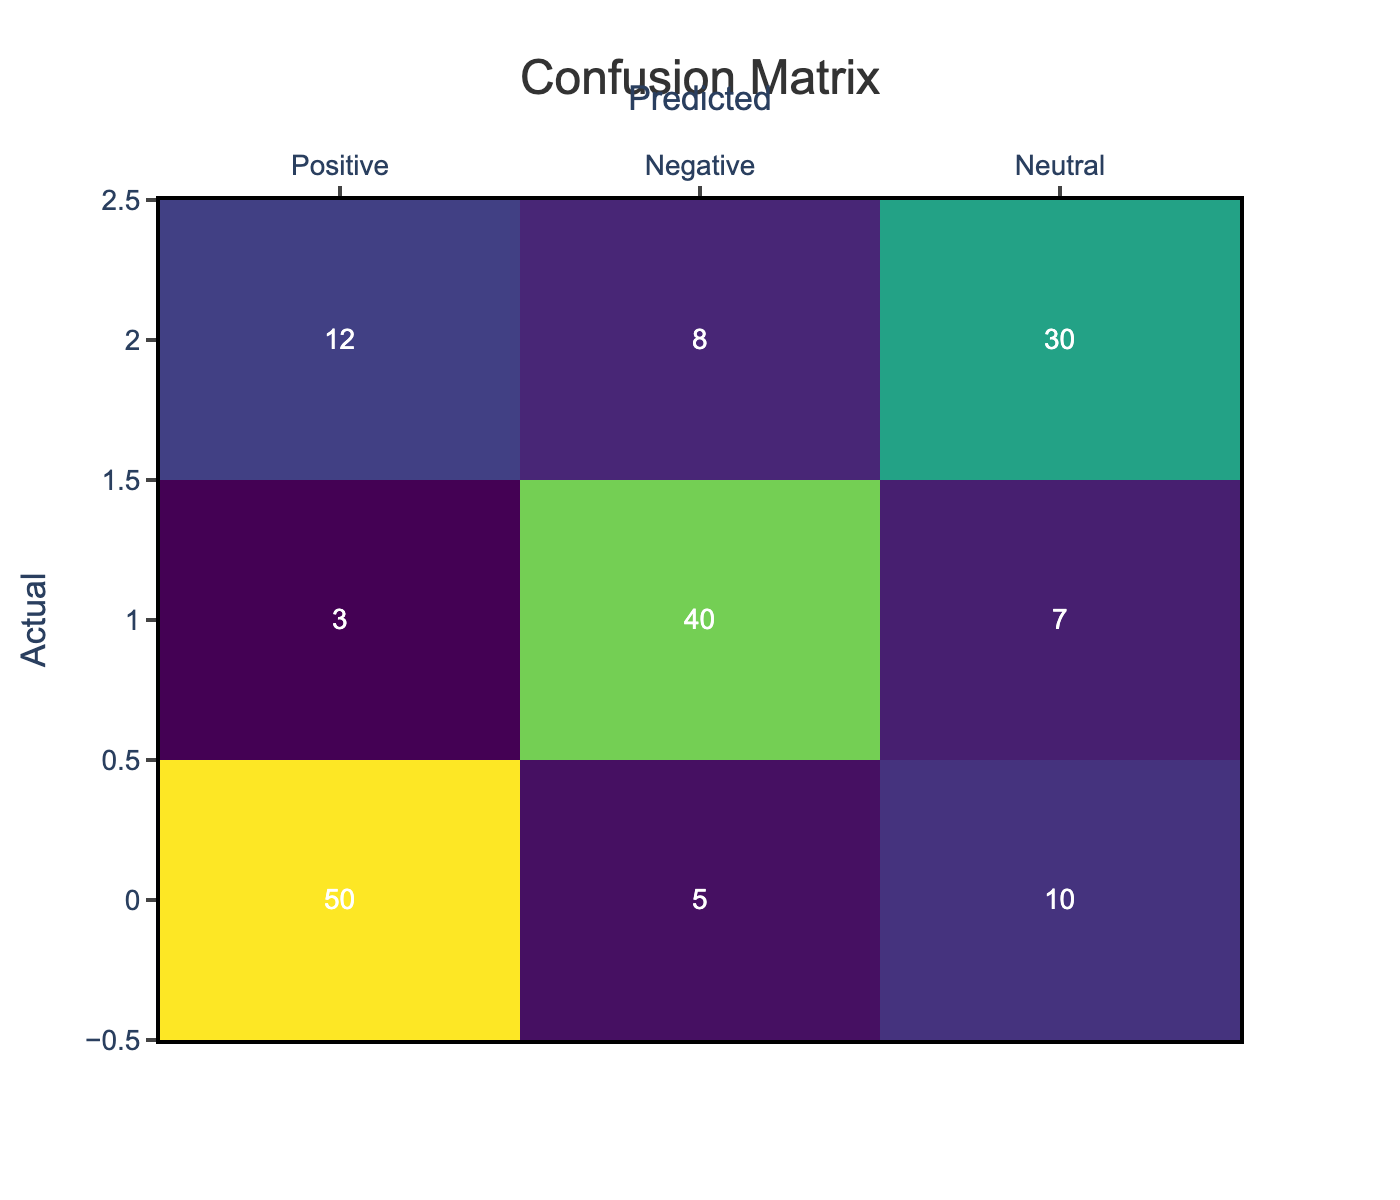What is the total number of actual positive cases? The actual positive cases are located in the first row of the table. To find the total, I add the values in the first row: 50 (True Positive) + 5 (False Negative) + 10 (Neutral) = 65.
Answer: 65 How many cases were incorrectly classified as negative? The cases incorrectly classified as negative are represented by the False Negative value within the Negative row. From the table, the False Negative cases (3) correspond to actual positives predicted as negatives, while the True Negative (40) represents the negatives correctly predicted.
Answer: 3 What is the total number of predicted neutral cases? To find the total predicted neutral cases, I need to look at the Neutral column. I will sum the values from all three rows: 10 (Positive) + 7 (Negative) + 30 (Neutral) = 47 predicted as neutral.
Answer: 47 Is the number of True Positives greater than the number of True Negatives? True Positives are given as 50, while True Negatives are 40. Since 50 is greater than 40, the statement is true.
Answer: Yes What percentage of actual neutral cases were accurately predicted? The actual neutral cases are the sum of the Neutral row (12 + 8 + 30 = 50). The accurately predicted neutral cases come from the True Positives in this row, which is 30. To calculate the percentage, I use the formula: (30 / 50) * 100 = 60%.
Answer: 60% What is the total number of negative predictions made? To find the total number of negative predictions, I need to sum the values in the Negative column: 3 (False Positive) + 40 (True Negative) + 8 (False Neutral) = 51 total negative predictions made.
Answer: 51 How many cases were classified as positive but should have been neutral? The cases that should have been neutral but were classified as positive are represented by the False Positive cases in the Positive row, which is 10.
Answer: 10 What is the ratio of True Positives to False Positives? True Positives are represented by 50, while False Positives are 5. The ratio is calculated as True Positives (50) divided by False Positives (5), giving a ratio of 50:5 which simplifies to 10:1.
Answer: 10:1 What is the total number of incorrectly classified cases across all categories? Incorrectly classified cases can be found by summing up all the False Positive values and False Negative values. In the table: 5 (False Positive from Positive) + 3 (False Negative from Negative) + 12 (False Negative from Neutral) + 7 (False Positive from Neutral) = 27 incorrectly classified cases.
Answer: 27 